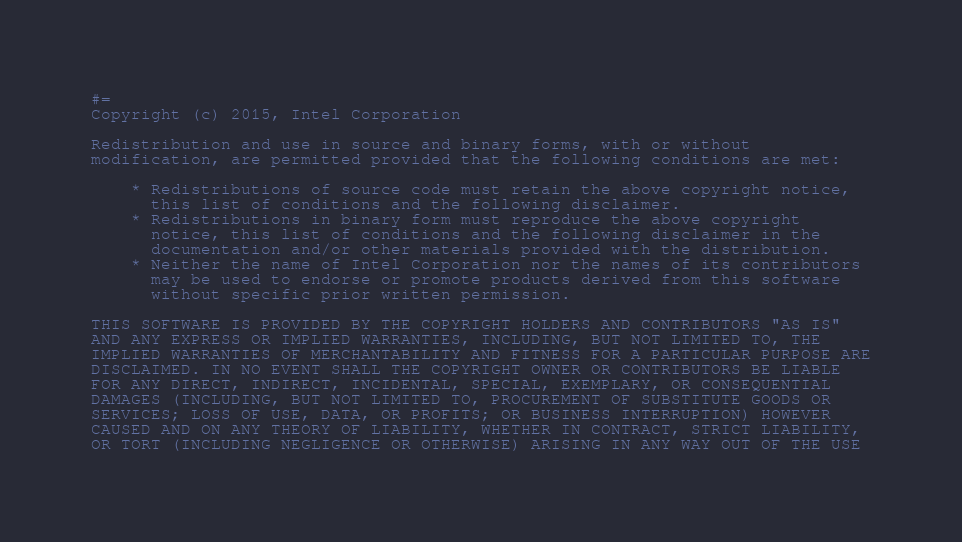Convert code to text. <code><loc_0><loc_0><loc_500><loc_500><_Julia_>#=
Copyright (c) 2015, Intel Corporation

Redistribution and use in source and binary forms, with or without
modification, are permitted provided that the following conditions are met:

    * Redistributions of source code must retain the above copyright notice,
      this list of conditions and the following disclaimer.
    * Redistributions in binary form must reproduce the above copyright
      notice, this list of conditions and the following disclaimer in the
      documentation and/or other materials provided with the distribution.
    * Neither the name of Intel Corporation nor the names of its contributors
      may be used to endorse or promote products derived from this software
      without specific prior written permission.

THIS SOFTWARE IS PROVIDED BY THE COPYRIGHT HOLDERS AND CONTRIBUTORS "AS IS"
AND ANY EXPRESS OR IMPLIED WARRANTIES, INCLUDING, BUT NOT LIMITED TO, THE
IMPLIED WARRANTIES OF MERCHANTABILITY AND FITNESS FOR A PARTICULAR PURPOSE ARE
DISCLAIMED. IN NO EVENT SHALL THE COPYRIGHT OWNER OR CONTRIBUTORS BE LIABLE
FOR ANY DIRECT, INDIRECT, INCIDENTAL, SPECIAL, EXEMPLARY, OR CONSEQUENTIAL
DAMAGES (INCLUDING, BUT NOT LIMITED TO, PROCUREMENT OF SUBSTITUTE GOODS OR
SERVICES; LOSS OF USE, DATA, OR PROFITS; OR BUSINESS INTERRUPTION) HOWEVER
CAUSED AND ON ANY THEORY OF LIABILITY, WHETHER IN CONTRACT, STRICT LIABILITY,
OR TORT (INCLUDING NEGLIGENCE OR OTHERWISE) ARISING IN ANY WAY OUT OF THE USE</code> 